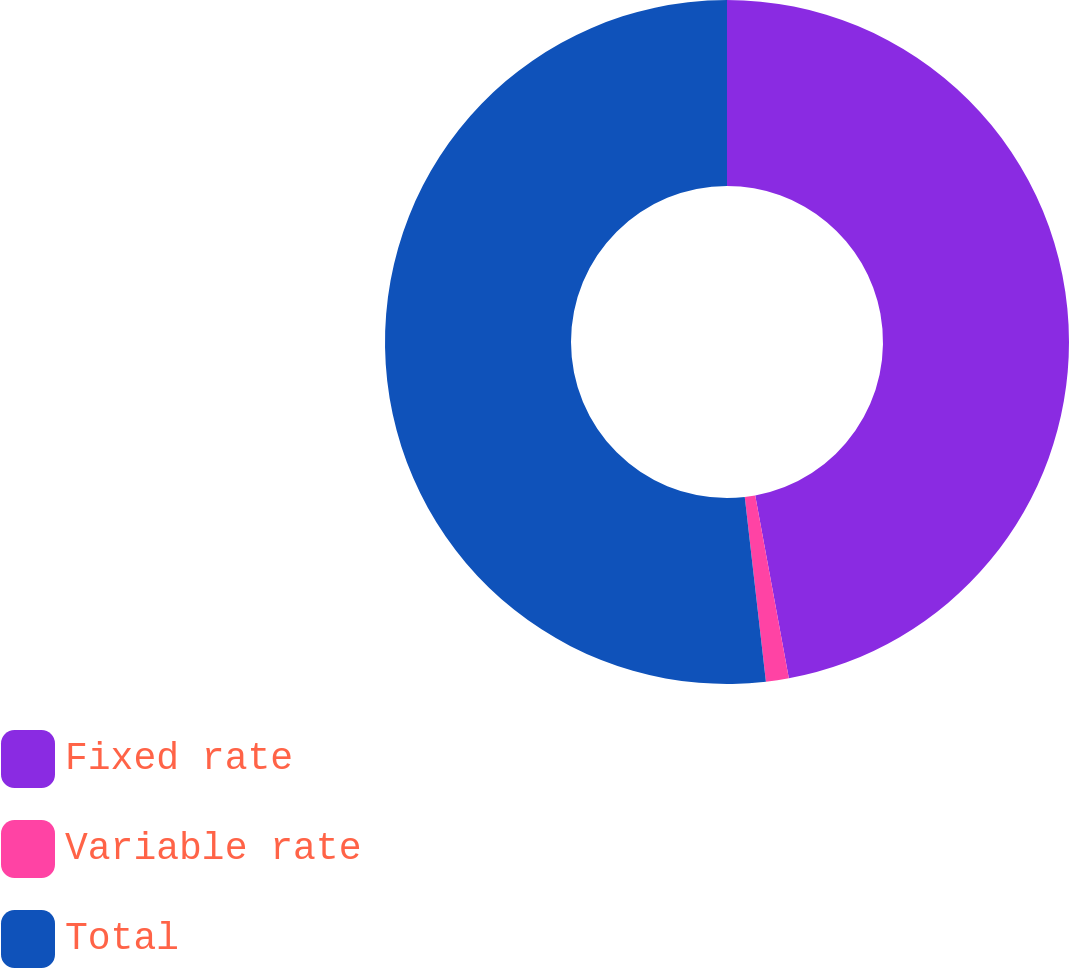Convert chart to OTSL. <chart><loc_0><loc_0><loc_500><loc_500><pie_chart><fcel>Fixed rate<fcel>Variable rate<fcel>Total<nl><fcel>47.11%<fcel>1.08%<fcel>51.82%<nl></chart> 